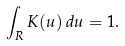<formula> <loc_0><loc_0><loc_500><loc_500>\int _ { R } K ( u ) \, d u = 1 .</formula> 